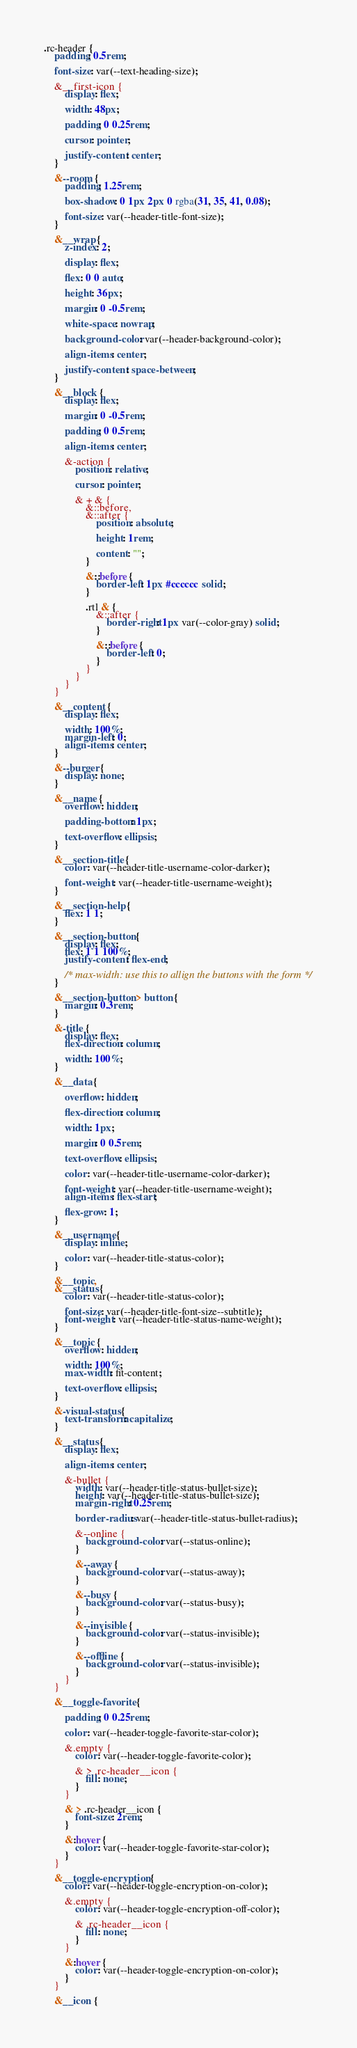Convert code to text. <code><loc_0><loc_0><loc_500><loc_500><_CSS_>.rc-header {
	padding: 0.5rem;

	font-size: var(--text-heading-size);

	&__first-icon {
		display: flex;

		width: 48px;

		padding: 0 0.25rem;

		cursor: pointer;

		justify-content: center;
	}

	&--room {
		padding: 1.25rem;

		box-shadow: 0 1px 2px 0 rgba(31, 35, 41, 0.08);

		font-size: var(--header-title-font-size);
	}

	&__wrap {
		z-index: 2;

		display: flex;

		flex: 0 0 auto;

		height: 36px;

		margin: 0 -0.5rem;

		white-space: nowrap;

		background-color: var(--header-background-color);

		align-items: center;

		justify-content: space-between;
	}

	&__block {
		display: flex;

		margin: 0 -0.5rem;

		padding: 0 0.5rem;

		align-items: center;

		&-action {
			position: relative;

			cursor: pointer;

			& + & {
				&::before,
				&::after {
					position: absolute;

					height: 1rem;

					content: "";
				}

				&::before {
					border-left: 1px #cccccc solid;
				}

				.rtl & {
					&::after {
						border-right: 1px var(--color-gray) solid;
					}

					&::before {
						border-left: 0;
					}
				}
			}
		}
	}

	&__content {
		display: flex;

		width: 100%;
		margin-left: 0;
		align-items: center;
	}

	&--burger {
		display: none;
	}

	&__name {
		overflow: hidden;

		padding-bottom: 1px;

		text-overflow: ellipsis;
	}

	&__section-title {
		color: var(--header-title-username-color-darker);

		font-weight: var(--header-title-username-weight);
	}

	&__section-help {
		flex: 1 1;
	}

	&__section-button {
		display: flex;
		flex: 1 1 100%;
		justify-content: flex-end;

		/* max-width: use this to allign the buttons with the form */
	}

	&__section-button > button {
		margin: 0.3rem;
	}

	&-title {
		display: flex;
		flex-direction: column;

		width: 100%;
	}

	&__data {

		overflow: hidden;

		flex-direction: column;

		width: 1px;

		margin: 0 0.5rem;

		text-overflow: ellipsis;

		color: var(--header-title-username-color-darker);

		font-weight: var(--header-title-username-weight);
		align-items: flex-start;

		flex-grow: 1;
	}

	&__username {
		display: inline;

		color: var(--header-title-status-color);
	}

	&__topic,
	&__status {
		color: var(--header-title-status-color);

		font-size: var(--header-title-font-size--subtitle);
		font-weight: var(--header-title-status-name-weight);
	}

	&__topic {
		overflow: hidden;

		width: 100%;
		max-width: fit-content;

		text-overflow: ellipsis;
	}

	&-visual-status {
		text-transform: capitalize;
	}

	&__status {
		display: flex;

		align-items: center;

		&-bullet {
			width: var(--header-title-status-bullet-size);
			height: var(--header-title-status-bullet-size);
			margin-right: 0.25rem;

			border-radius: var(--header-title-status-bullet-radius);

			&--online {
				background-color: var(--status-online);
			}

			&--away {
				background-color: var(--status-away);
			}

			&--busy {
				background-color: var(--status-busy);
			}

			&--invisible {
				background-color: var(--status-invisible);
			}

			&--offline {
				background-color: var(--status-invisible);
			}
		}
	}

	&__toggle-favorite {

		padding: 0 0.25rem;

		color: var(--header-toggle-favorite-star-color);

		&.empty {
			color: var(--header-toggle-favorite-color);

			& > .rc-header__icon {
				fill: none;
			}
		}

		& > .rc-header__icon {
			font-size: 2rem;
		}

		&:hover {
			color: var(--header-toggle-favorite-star-color);
		}
	}

	&__toggle-encryption {
		color: var(--header-toggle-encryption-on-color);

		&.empty {
			color: var(--header-toggle-encryption-off-color);

			& .rc-header__icon {
				fill: none;
			}
		}

		&:hover {
			color: var(--header-toggle-encryption-on-color);
		}
	}

	&__icon {</code> 